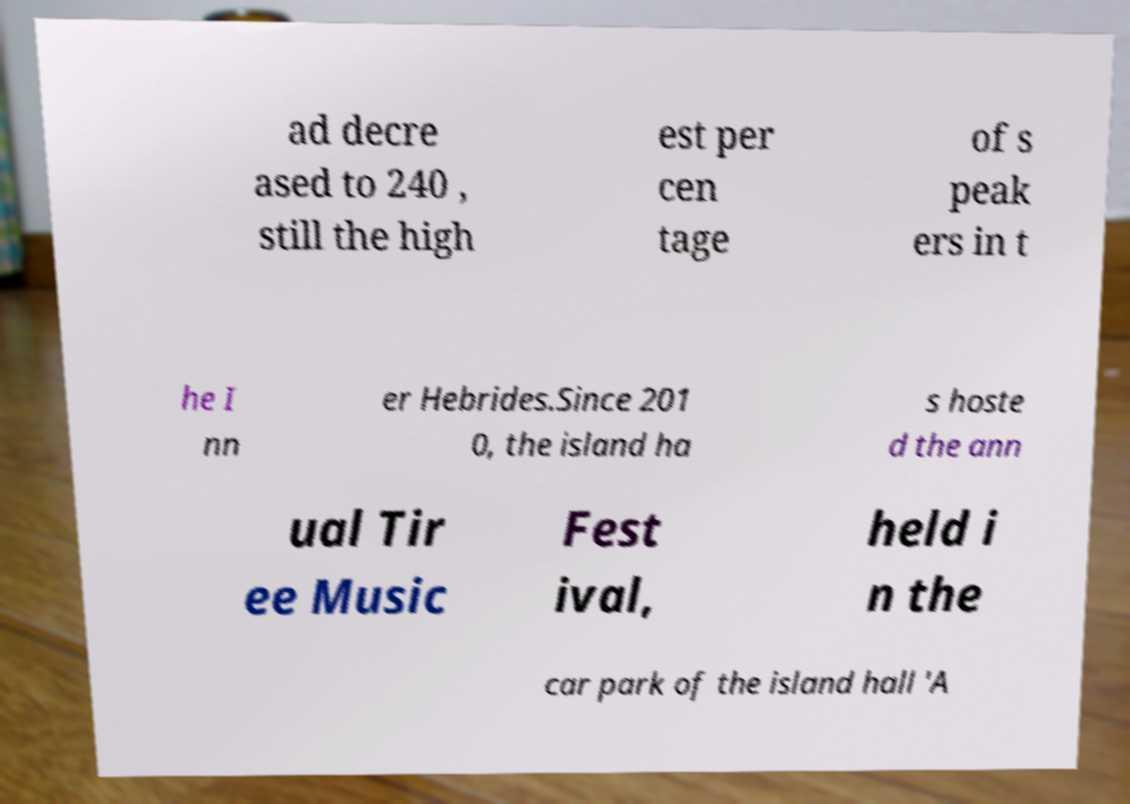Could you extract and type out the text from this image? ad decre ased to 240 , still the high est per cen tage of s peak ers in t he I nn er Hebrides.Since 201 0, the island ha s hoste d the ann ual Tir ee Music Fest ival, held i n the car park of the island hall 'A 